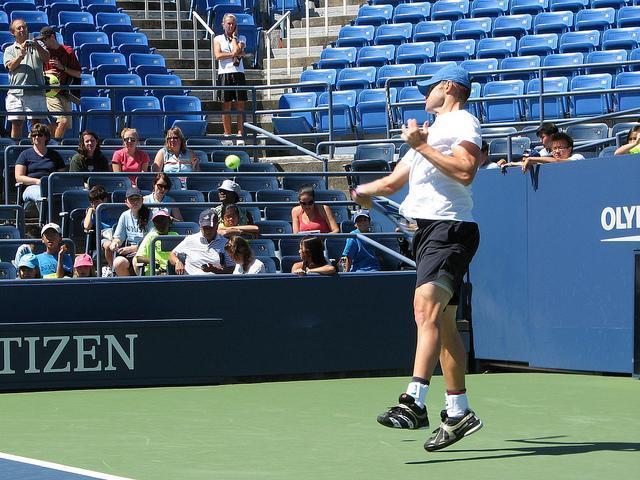How many people are in the photo?
Give a very brief answer. 5. 